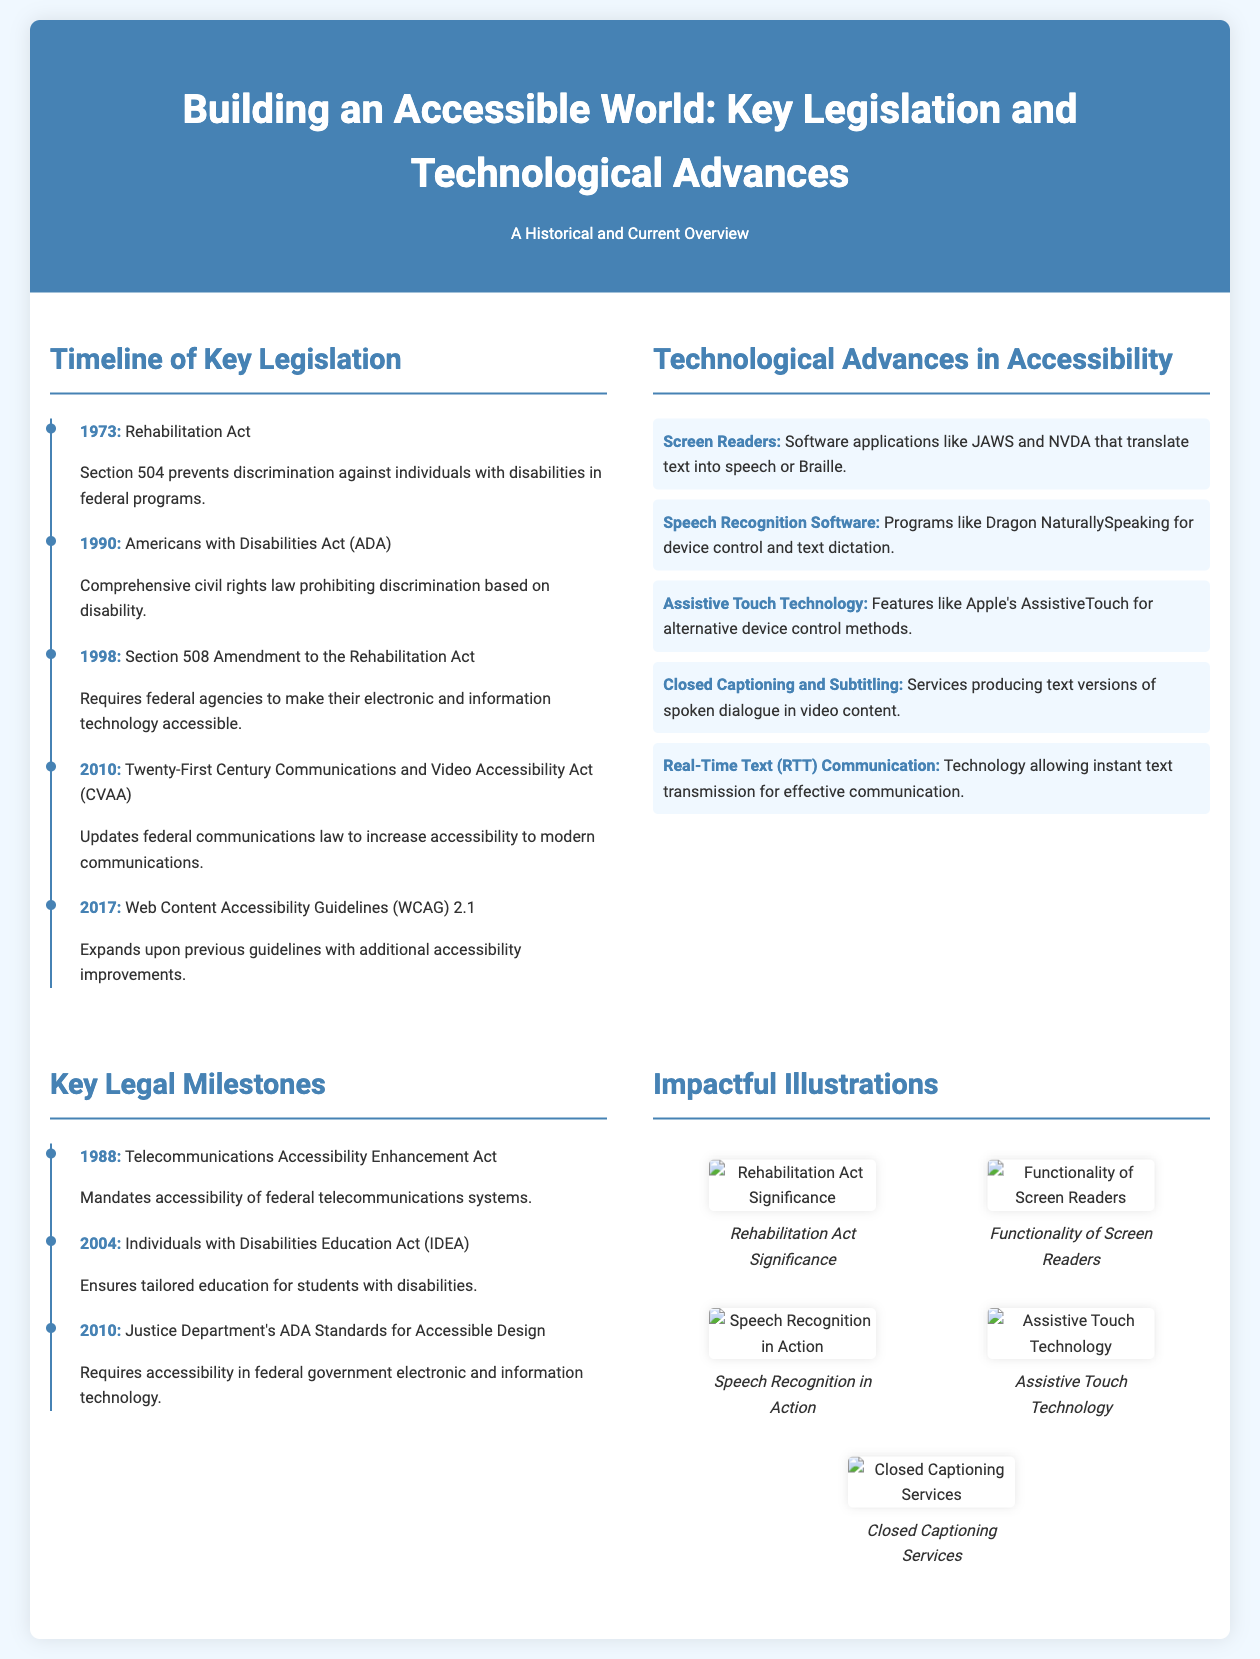what year was the Rehabilitation Act enacted? The Rehabilitation Act was enacted in 1973 as noted in the timeline section.
Answer: 1973 what does the ADA stand for? The acronym ADA stands for the Americans with Disabilities Act, mentioned in the key legislation section.
Answer: Americans with Disabilities Act which technology is designed for text-to-speech conversion? Screen Readers are the technology designed for converting text to speech as stated in the technological advances section.
Answer: Screen Readers what significant act was amended in 1998? The amendment in 1998 is related to the Rehabilitation Act, specifically Section 508.
Answer: Rehabilitation Act how many key legal milestones are listed in the document? The document lists three key legal milestones in the respective section under Key Legal Milestones.
Answer: Three what type of software is Dragon NaturallySpeaking? Dragon NaturallySpeaking is categorized as Speech Recognition Software, as mentioned in the technological advances section.
Answer: Speech Recognition Software which accessibility guideline was updated in 2017? The Web Content Accessibility Guidelines (WCAG) were updated in 2017 according to the timeline of key legislation.
Answer: Web Content Accessibility Guidelines (WCAG) what year marks the introduction of the CVAA? The introduction year of the Twenty-First Century Communications and Video Accessibility Act (CVAA) is 2010, as stated in the timeline.
Answer: 2010 which act ensures education for students with disabilities? The Individuals with Disabilities Education Act (IDEA) ensures tailored education for students with disabilities as mentioned in the key legal milestones.
Answer: Individuals with Disabilities Education Act (IDEA) 